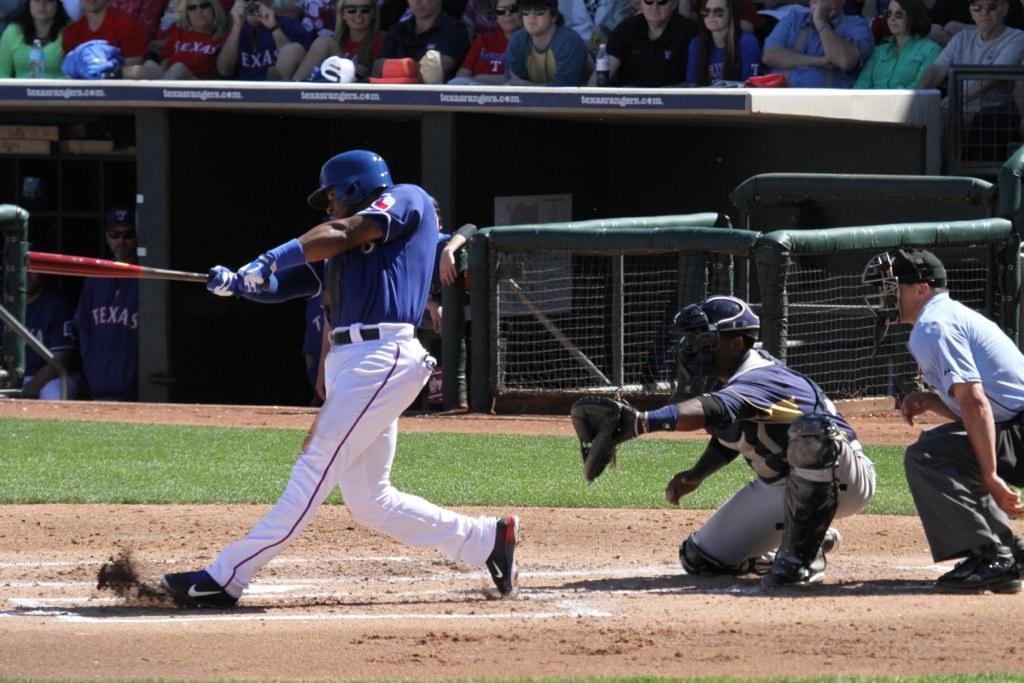<image>
Provide a brief description of the given image. A baseball player wearing a blue shirt that says Texas on it swinging at a ball. 